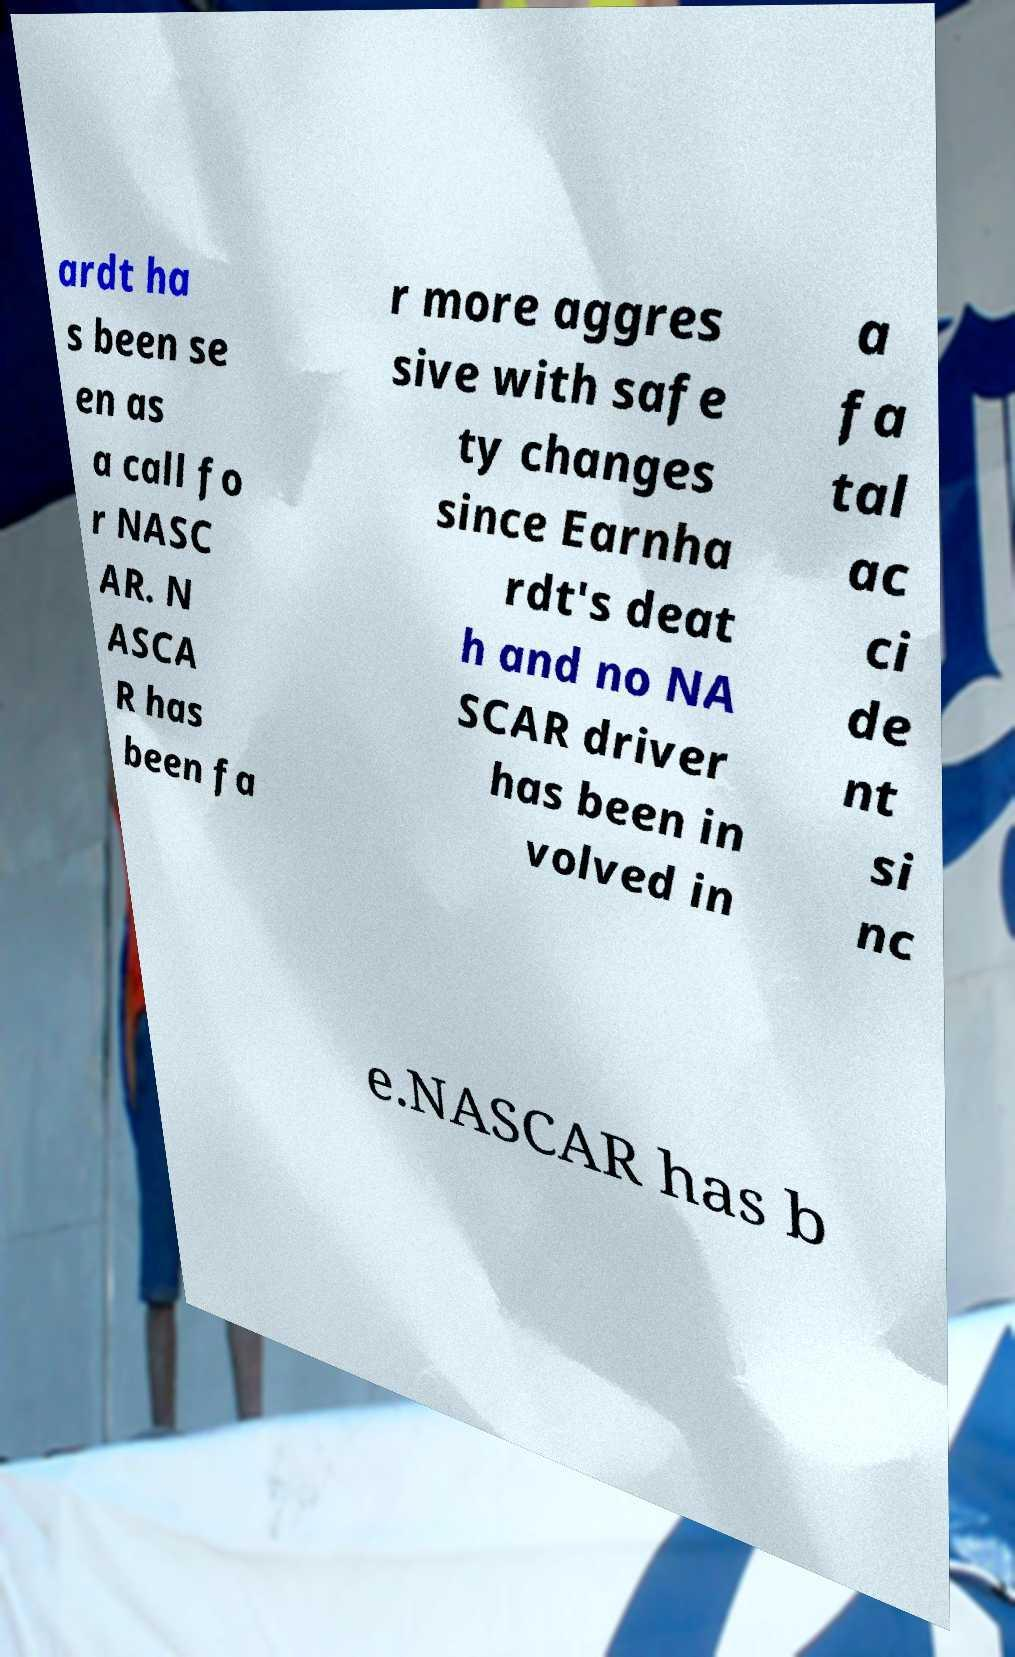What messages or text are displayed in this image? I need them in a readable, typed format. ardt ha s been se en as a call fo r NASC AR. N ASCA R has been fa r more aggres sive with safe ty changes since Earnha rdt's deat h and no NA SCAR driver has been in volved in a fa tal ac ci de nt si nc e.NASCAR has b 